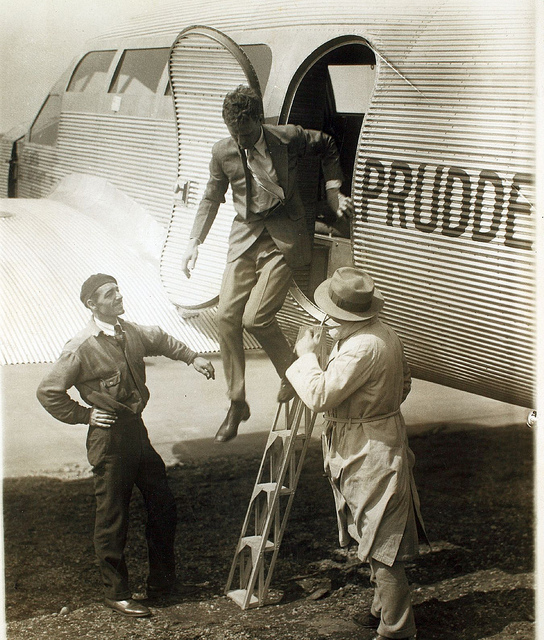Identify and read out the text in this image. PRUDDE 